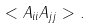Convert formula to latex. <formula><loc_0><loc_0><loc_500><loc_500>< A _ { i i } A _ { j j } > .</formula> 